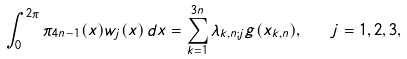Convert formula to latex. <formula><loc_0><loc_0><loc_500><loc_500>\int _ { 0 } ^ { 2 \pi } \pi _ { 4 n - 1 } ( x ) w _ { j } ( x ) \, d x = \sum _ { k = 1 } ^ { 3 n } \lambda _ { k , n ; j } g ( x _ { k , n } ) , \quad j = 1 , 2 , 3 ,</formula> 